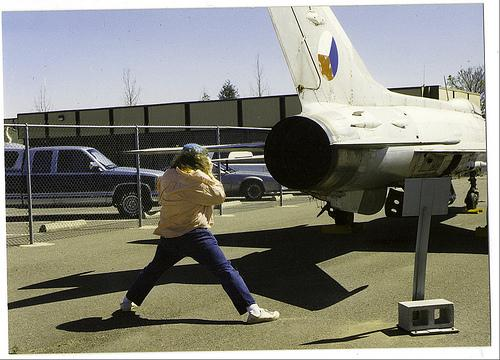Question: where is the man?
Choices:
A. In the cockpit.
B. Near the wing.
C. Behind the plane.
D. By the landing gear.
Answer with the letter. Answer: C Question: what is he wearing?
Choices:
A. Hoodie.
B. Jacket.
C. Trench coat.
D. Sweater.
Answer with the letter. Answer: B Question: how many jets?
Choices:
A. 2.
B. 3.
C. 4.
D. 1.
Answer with the letter. Answer: D 